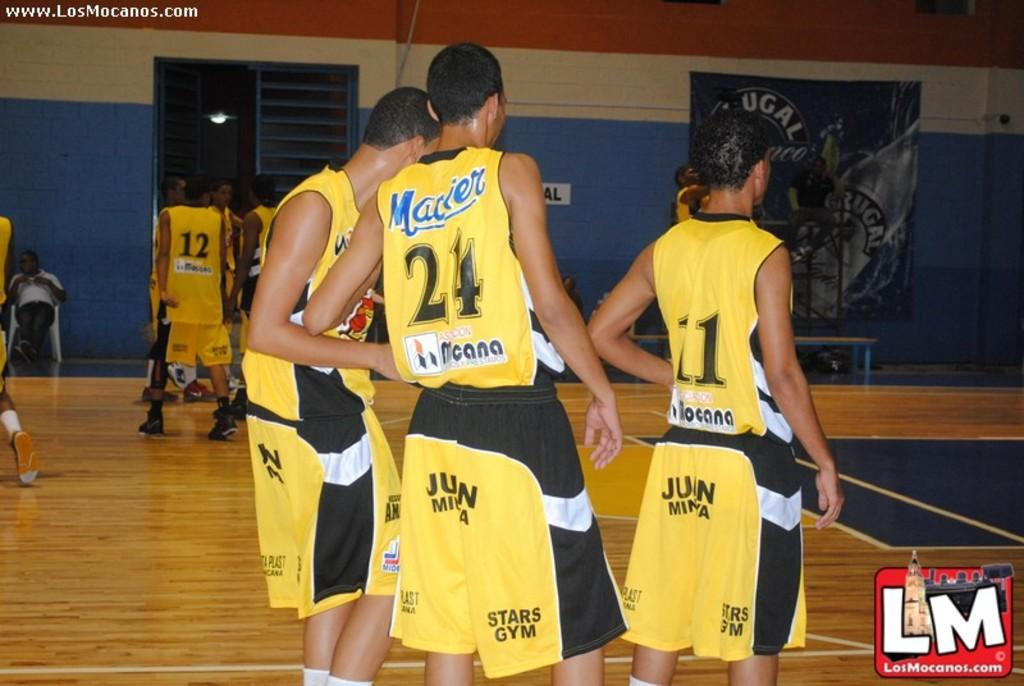<image>
Summarize the visual content of the image. A basketball player wearing a yellow number 24 jersey with his teammates. 